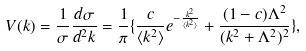Convert formula to latex. <formula><loc_0><loc_0><loc_500><loc_500>V ( { k } ) = \frac { 1 } { \sigma } \frac { d \sigma } { d ^ { 2 } { k } } = \frac { 1 } { \pi } \{ \frac { c } { \langle { k } ^ { 2 } \rangle } e ^ { - \frac { { k } ^ { 2 } } { \langle { k } ^ { 2 } \rangle } } + \frac { ( 1 - c ) \Lambda ^ { 2 } } { ( { k } ^ { 2 } + \Lambda ^ { 2 } ) ^ { 2 } } \} ,</formula> 